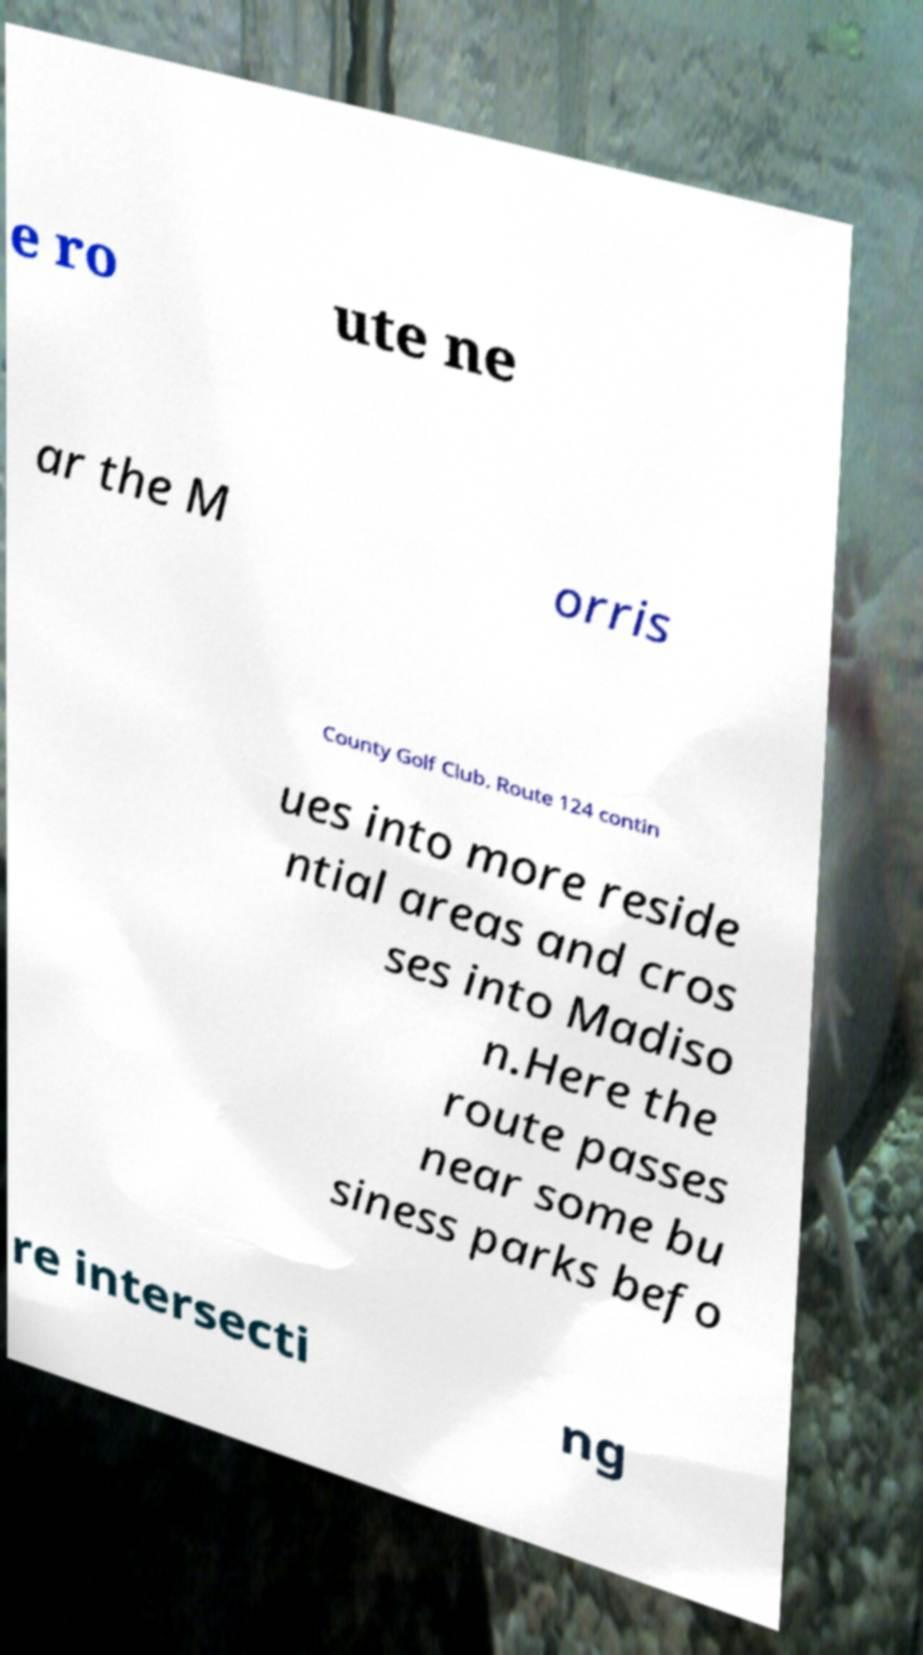For documentation purposes, I need the text within this image transcribed. Could you provide that? e ro ute ne ar the M orris County Golf Club. Route 124 contin ues into more reside ntial areas and cros ses into Madiso n.Here the route passes near some bu siness parks befo re intersecti ng 